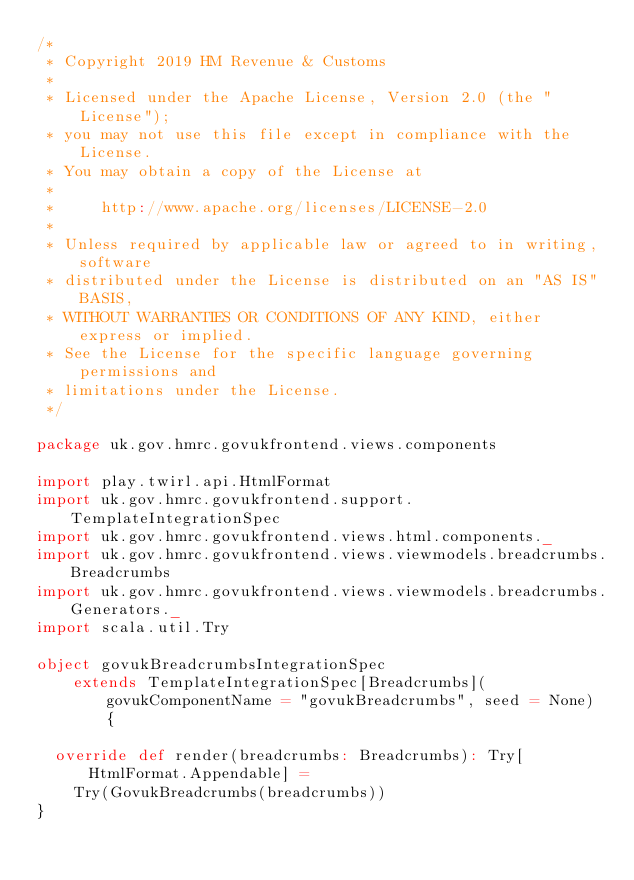<code> <loc_0><loc_0><loc_500><loc_500><_Scala_>/*
 * Copyright 2019 HM Revenue & Customs
 *
 * Licensed under the Apache License, Version 2.0 (the "License");
 * you may not use this file except in compliance with the License.
 * You may obtain a copy of the License at
 *
 *     http://www.apache.org/licenses/LICENSE-2.0
 *
 * Unless required by applicable law or agreed to in writing, software
 * distributed under the License is distributed on an "AS IS" BASIS,
 * WITHOUT WARRANTIES OR CONDITIONS OF ANY KIND, either express or implied.
 * See the License for the specific language governing permissions and
 * limitations under the License.
 */

package uk.gov.hmrc.govukfrontend.views.components

import play.twirl.api.HtmlFormat
import uk.gov.hmrc.govukfrontend.support.TemplateIntegrationSpec
import uk.gov.hmrc.govukfrontend.views.html.components._
import uk.gov.hmrc.govukfrontend.views.viewmodels.breadcrumbs.Breadcrumbs
import uk.gov.hmrc.govukfrontend.views.viewmodels.breadcrumbs.Generators._
import scala.util.Try

object govukBreadcrumbsIntegrationSpec
    extends TemplateIntegrationSpec[Breadcrumbs](govukComponentName = "govukBreadcrumbs", seed = None) {

  override def render(breadcrumbs: Breadcrumbs): Try[HtmlFormat.Appendable] =
    Try(GovukBreadcrumbs(breadcrumbs))
}
</code> 